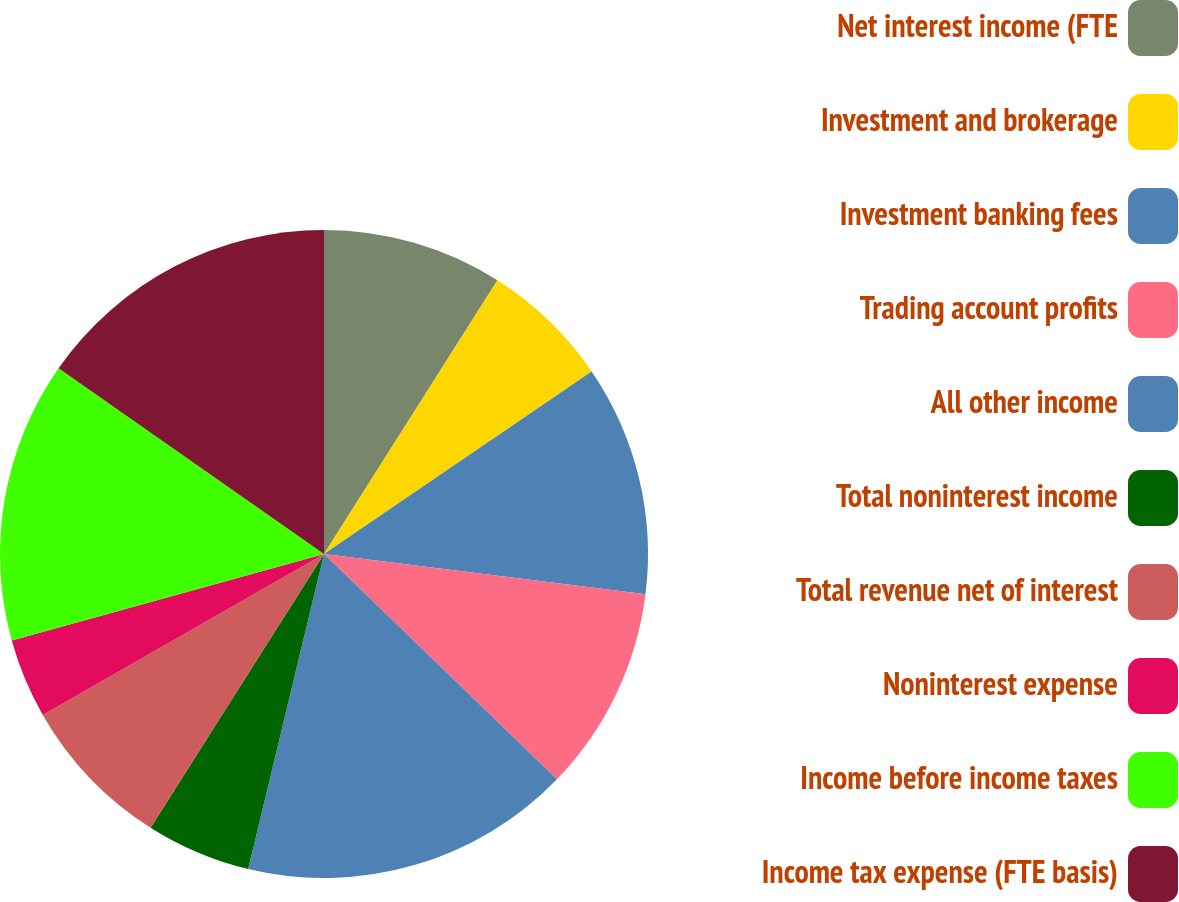Convert chart to OTSL. <chart><loc_0><loc_0><loc_500><loc_500><pie_chart><fcel>Net interest income (FTE<fcel>Investment and brokerage<fcel>Investment banking fees<fcel>Trading account profits<fcel>All other income<fcel>Total noninterest income<fcel>Total revenue net of interest<fcel>Noninterest expense<fcel>Income before income taxes<fcel>Income tax expense (FTE basis)<nl><fcel>8.99%<fcel>6.48%<fcel>11.51%<fcel>10.25%<fcel>16.53%<fcel>5.23%<fcel>7.74%<fcel>3.97%<fcel>14.02%<fcel>15.28%<nl></chart> 